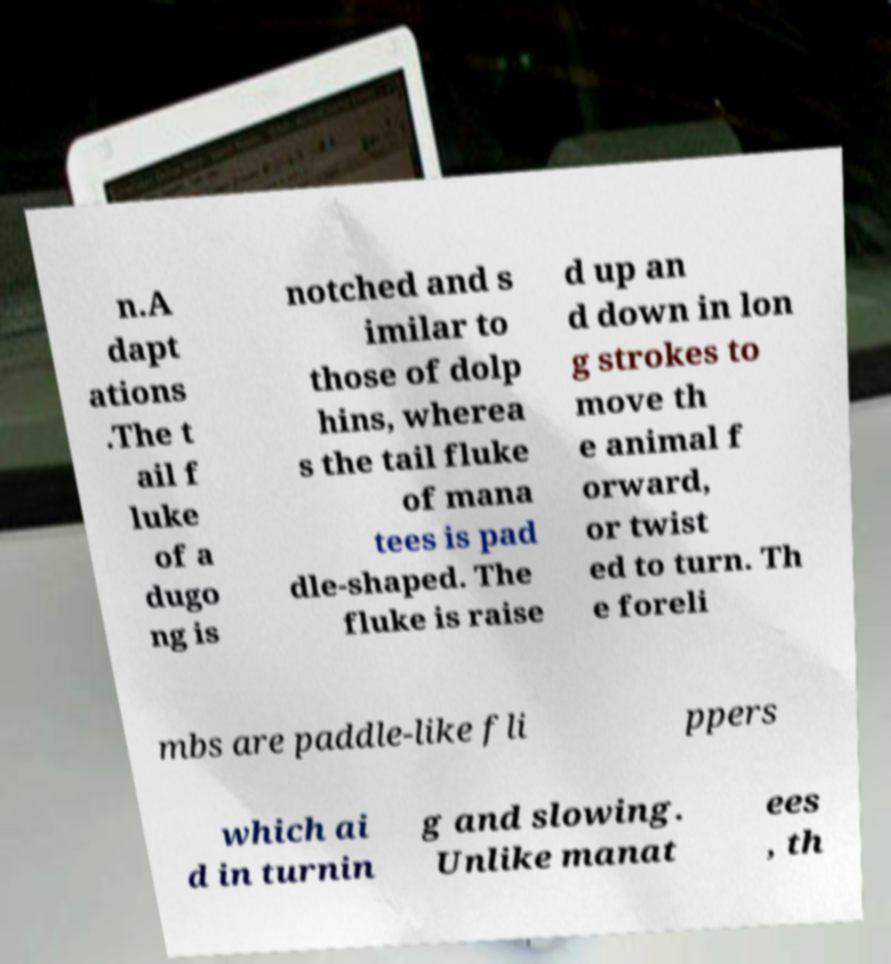Could you assist in decoding the text presented in this image and type it out clearly? n.A dapt ations .The t ail f luke of a dugo ng is notched and s imilar to those of dolp hins, wherea s the tail fluke of mana tees is pad dle-shaped. The fluke is raise d up an d down in lon g strokes to move th e animal f orward, or twist ed to turn. Th e foreli mbs are paddle-like fli ppers which ai d in turnin g and slowing. Unlike manat ees , th 